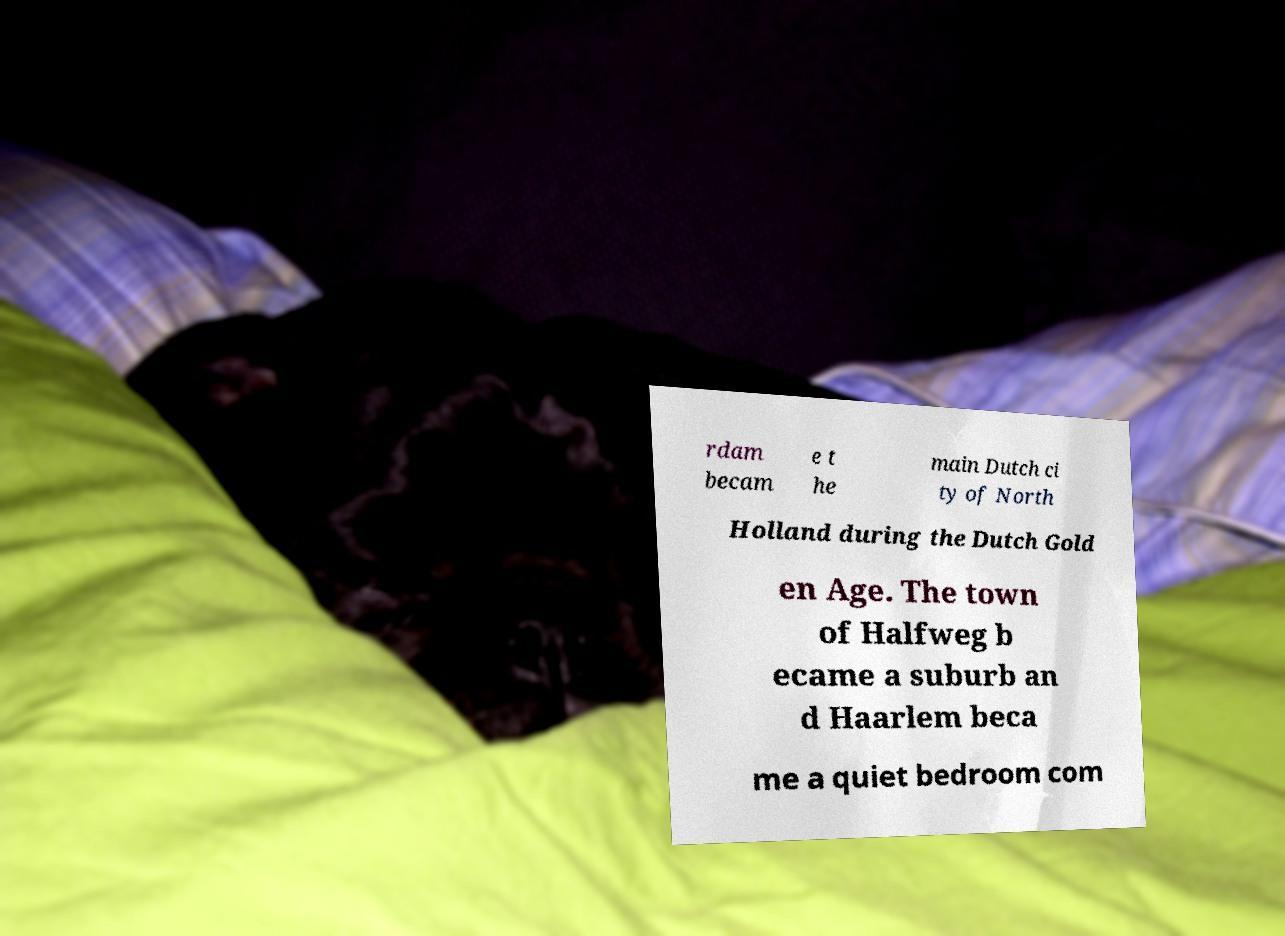Could you assist in decoding the text presented in this image and type it out clearly? rdam becam e t he main Dutch ci ty of North Holland during the Dutch Gold en Age. The town of Halfweg b ecame a suburb an d Haarlem beca me a quiet bedroom com 